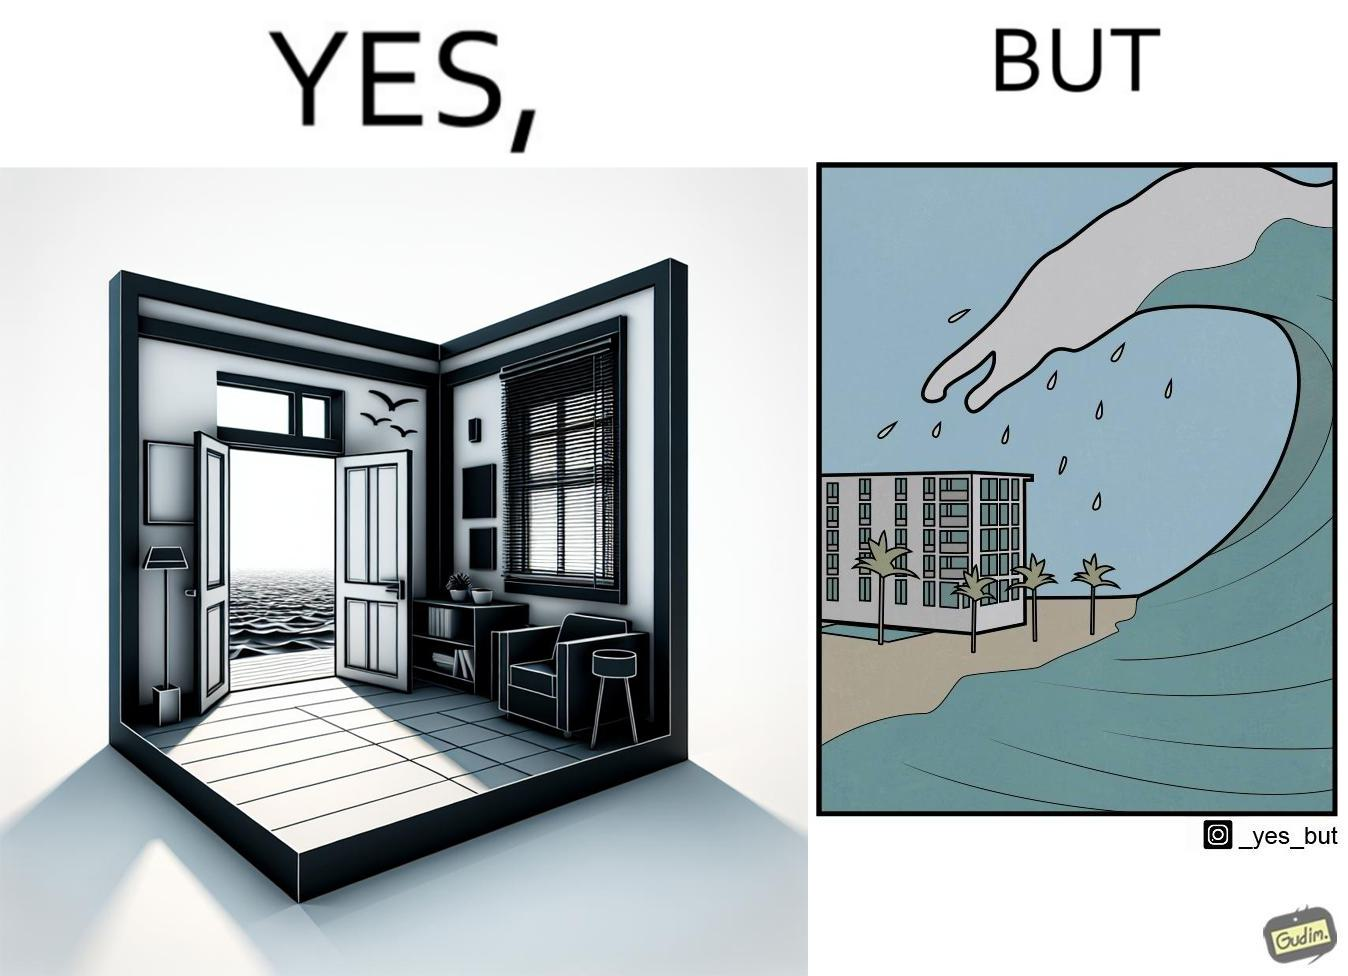Describe the content of this image. The same sea which gives us a relaxation on a normal day can pose a danger to us sometimes like during a tsunami 